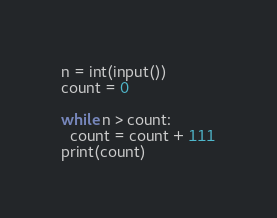<code> <loc_0><loc_0><loc_500><loc_500><_Python_>n = int(input())
count = 0

while n > count:
  count = count + 111
print(count)</code> 